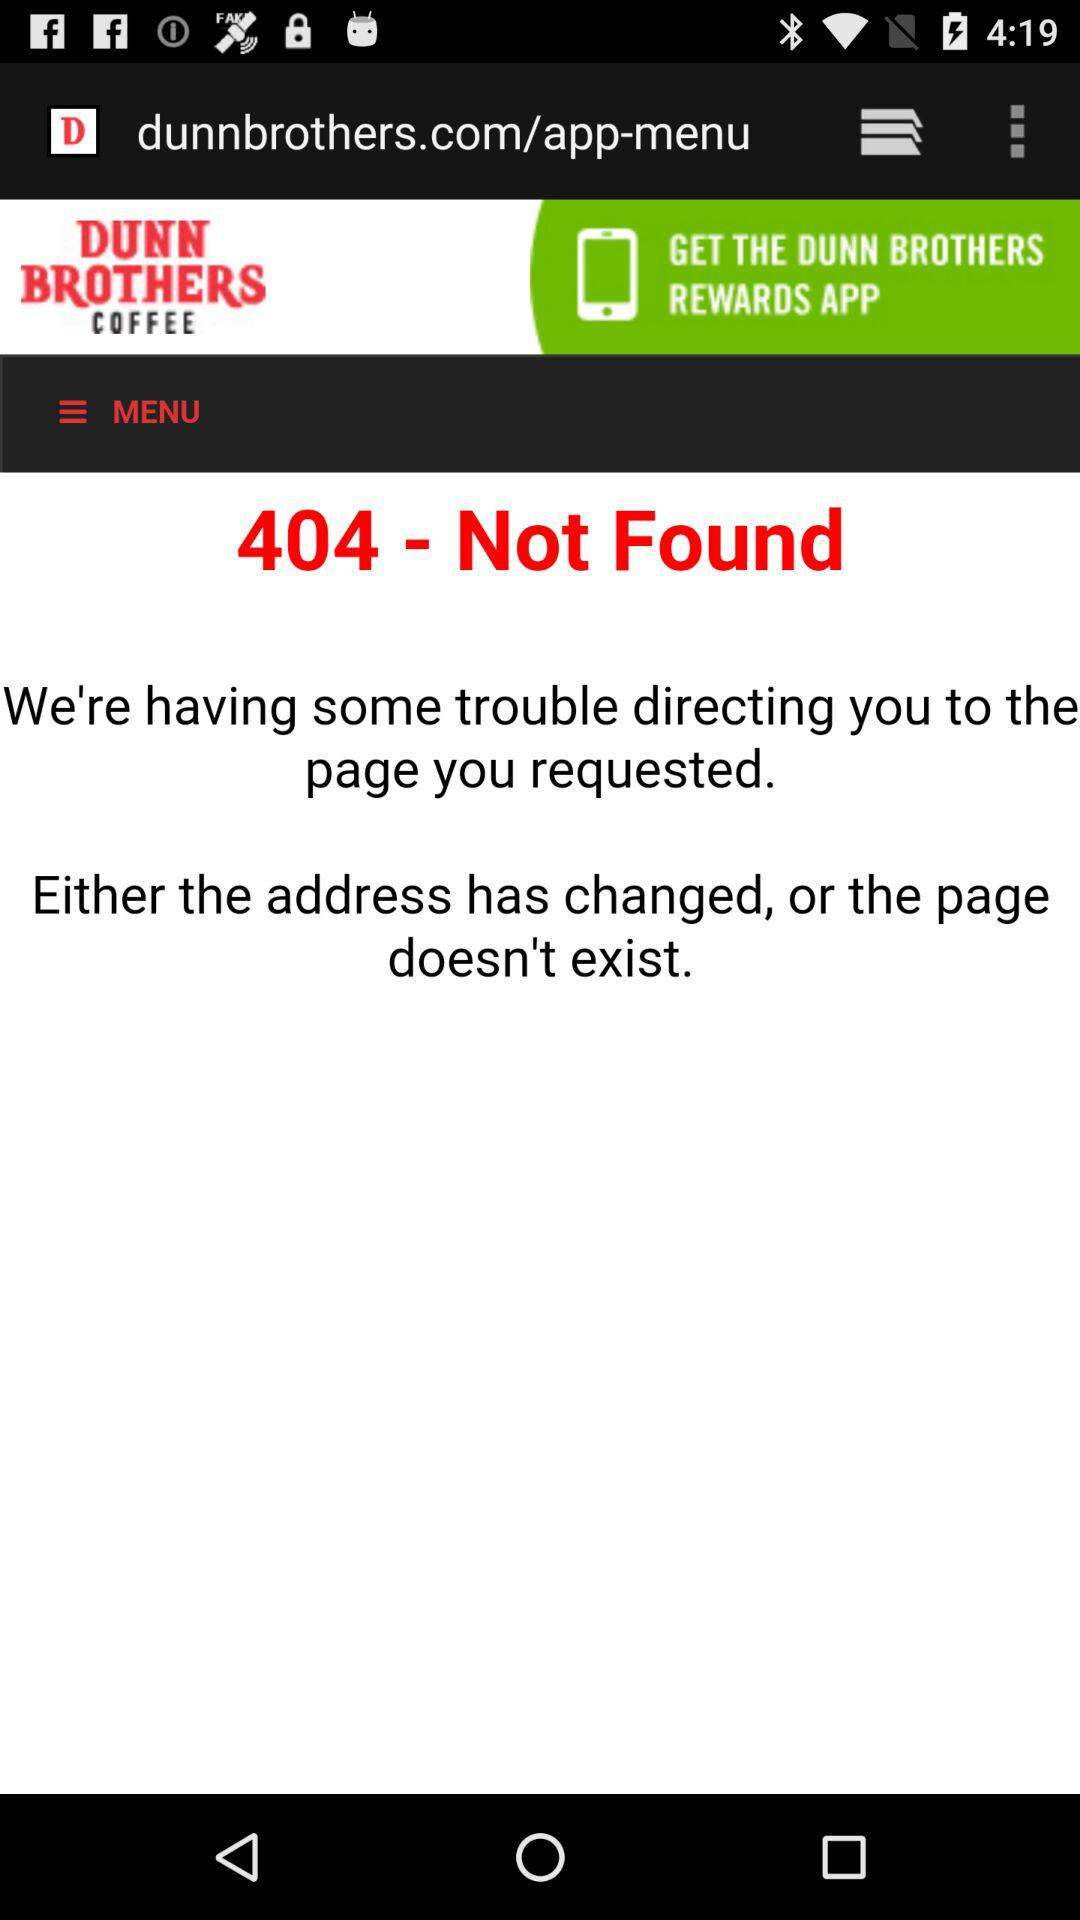What is the name of the application shown here? The name of the application shown here is "DUNN BROTHERS COFFEE". 